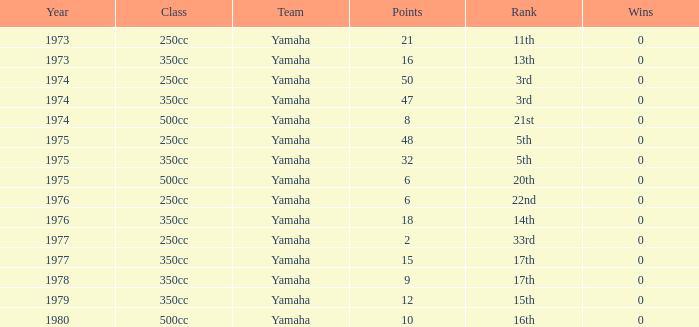Which Wins is the highest one that has a Class of 500cc, and Points smaller than 6? None. 